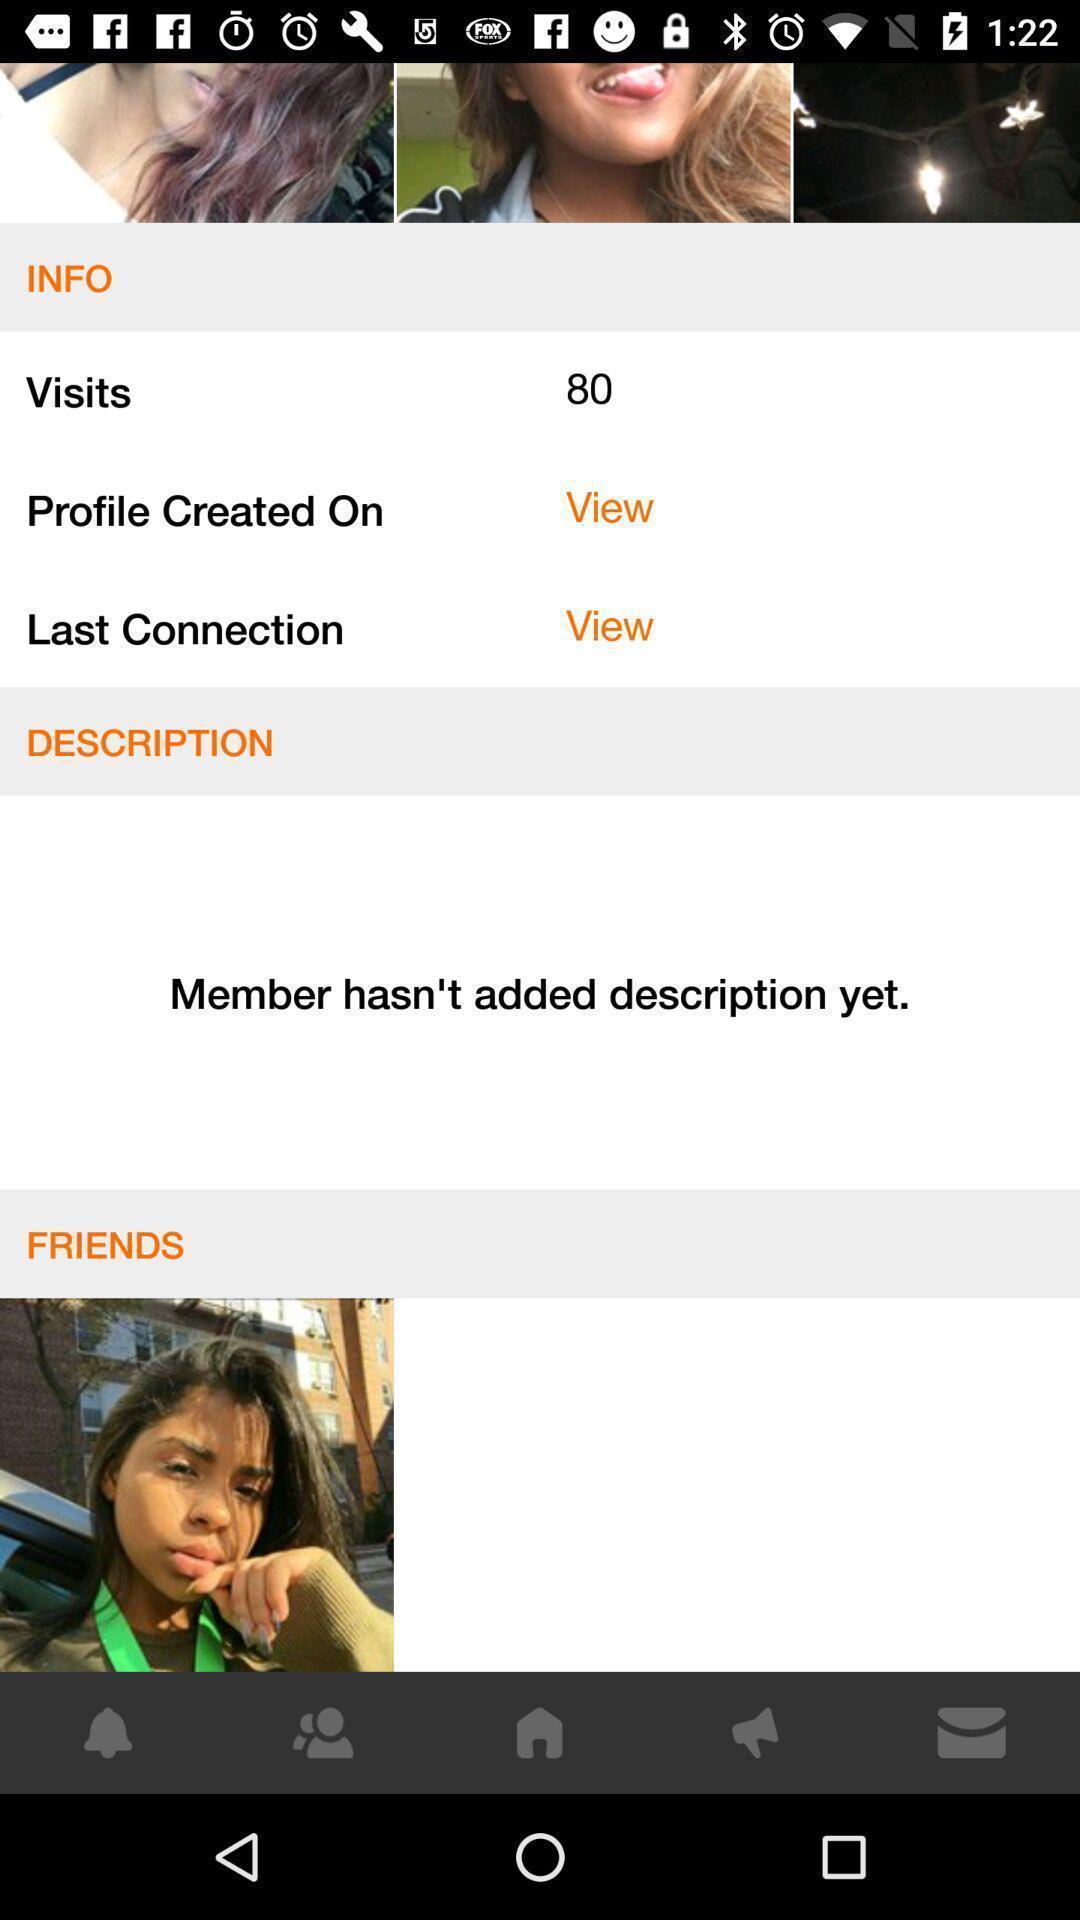Explain the elements present in this screenshot. Screen displaying the page of a social app. 